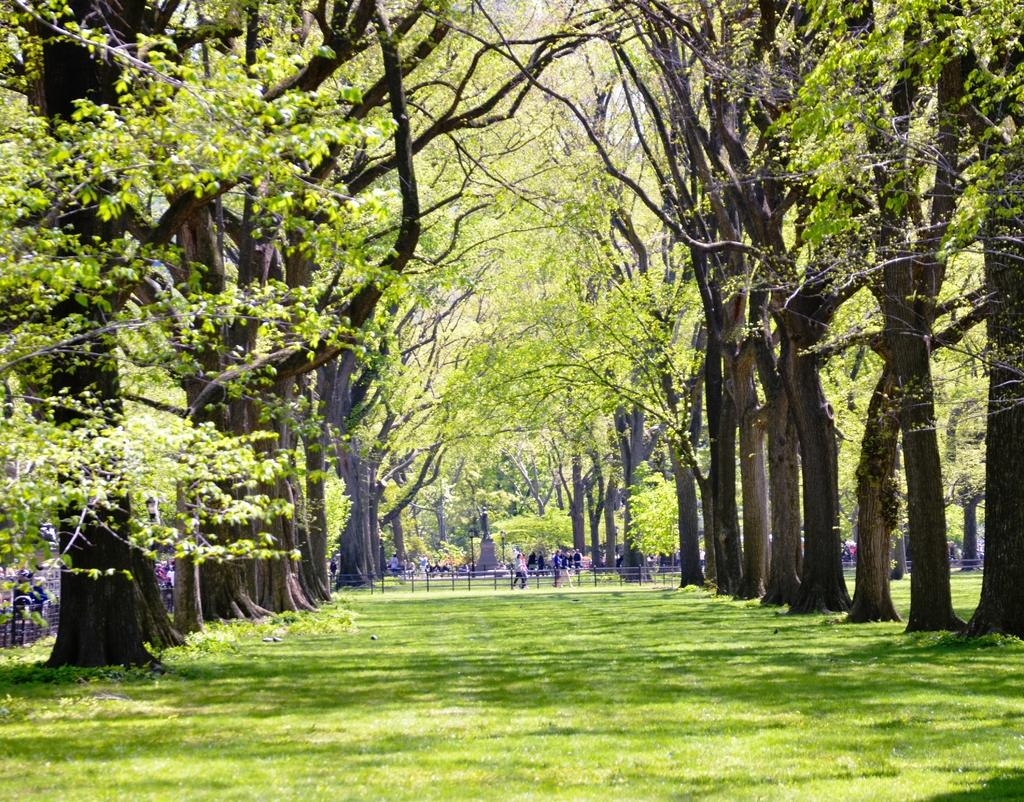What is located in the middle of the image? There are trees in the middle of the image. What can be seen in the background of the image? There are people visible in the background of the image. What type of vegetation is present at the bottom of the image? Grass is present at the bottom of the image. How many cherries are on the cap of the person in the image? There are no cherries or caps present in the image. What type of team is visible in the image? There is no team visible in the image; it features trees, people, and grass. 